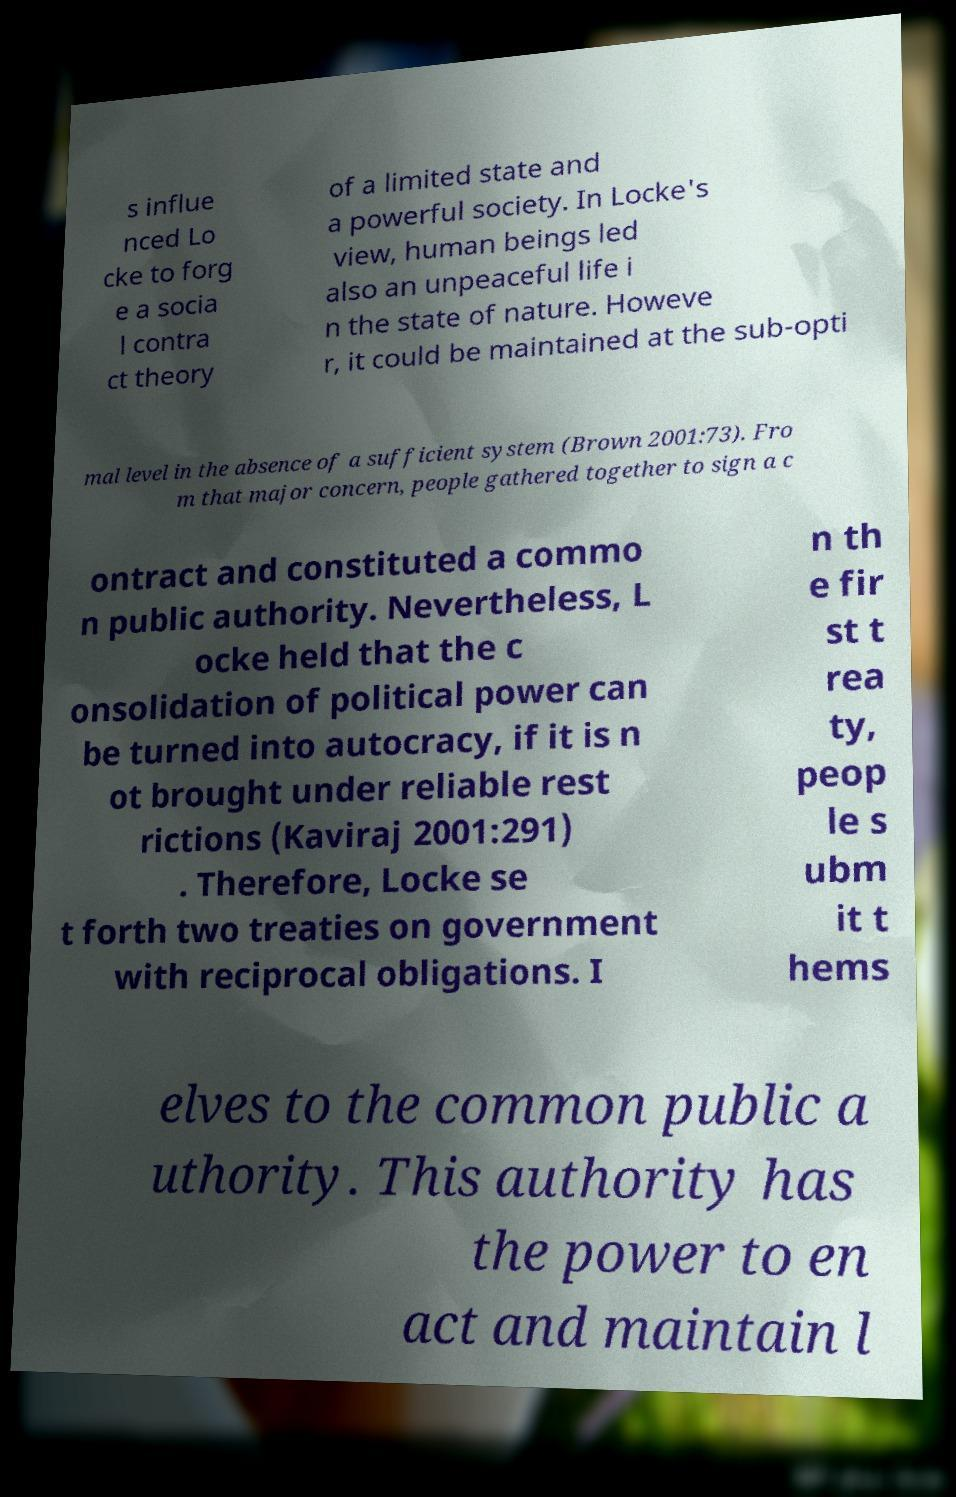Could you extract and type out the text from this image? s influe nced Lo cke to forg e a socia l contra ct theory of a limited state and a powerful society. In Locke's view, human beings led also an unpeaceful life i n the state of nature. Howeve r, it could be maintained at the sub-opti mal level in the absence of a sufficient system (Brown 2001:73). Fro m that major concern, people gathered together to sign a c ontract and constituted a commo n public authority. Nevertheless, L ocke held that the c onsolidation of political power can be turned into autocracy, if it is n ot brought under reliable rest rictions (Kaviraj 2001:291) . Therefore, Locke se t forth two treaties on government with reciprocal obligations. I n th e fir st t rea ty, peop le s ubm it t hems elves to the common public a uthority. This authority has the power to en act and maintain l 